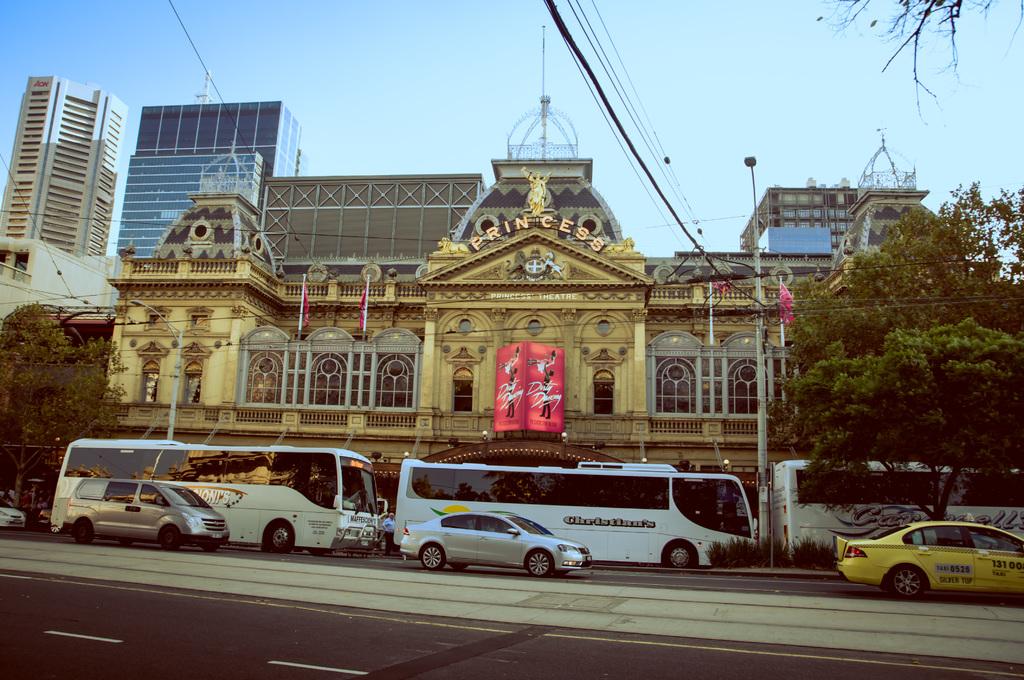What is the name on the top of the building?
Make the answer very short. Princess. What movie is playing?
Your answer should be compact. Dirty dancing. 